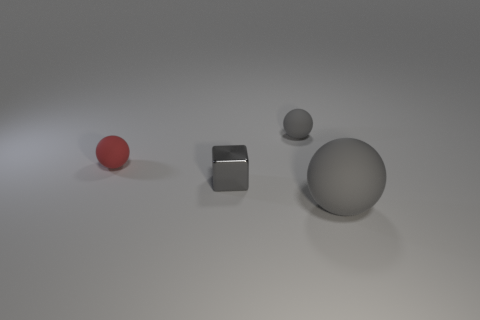What number of gray rubber things are the same shape as the tiny red thing?
Your response must be concise. 2. Are there any gray blocks made of the same material as the red ball?
Provide a succinct answer. No. What material is the ball that is to the right of the gray rubber object behind the small red rubber sphere made of?
Provide a succinct answer. Rubber. What is the size of the rubber sphere in front of the metallic object?
Your answer should be very brief. Large. There is a tiny block; is it the same color as the object that is behind the small red rubber ball?
Your answer should be compact. Yes. Is there a large object that has the same color as the tiny metallic block?
Offer a very short reply. Yes. Are the tiny gray block and the ball that is in front of the red object made of the same material?
Keep it short and to the point. No. What number of big things are either cyan metal blocks or gray matte things?
Your answer should be very brief. 1. There is a small sphere that is the same color as the big rubber ball; what material is it?
Provide a succinct answer. Rubber. Are there fewer big blue shiny things than gray rubber spheres?
Make the answer very short. Yes. 